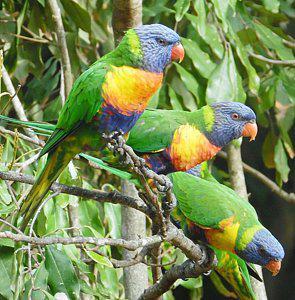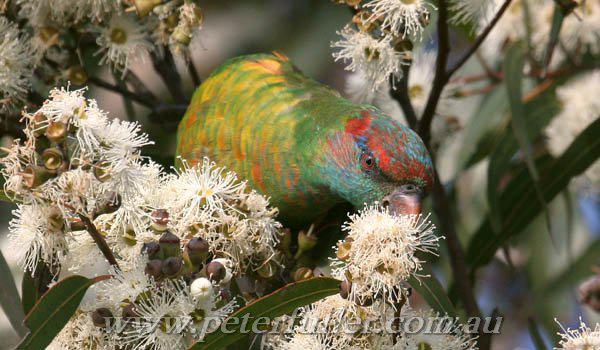The first image is the image on the left, the second image is the image on the right. Considering the images on both sides, is "There are four parrots." valid? Answer yes or no. Yes. The first image is the image on the left, the second image is the image on the right. Examine the images to the left and right. Is the description "there are 4 parrots in the image pair" accurate? Answer yes or no. Yes. 